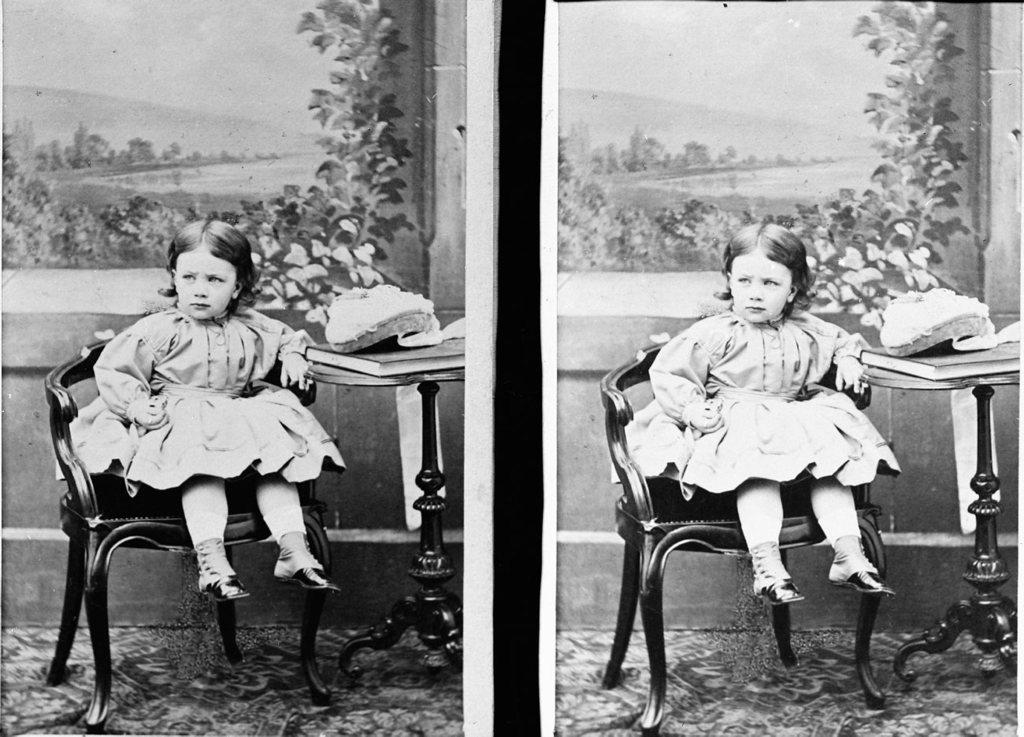What is the girl doing in the image? The girl is seated on a chair in the image. What object can be seen on a table in the image? There is a book on a table in the image. What type of pan is being used by the girl in the image? There is no pan present in the image; the girl is seated on a chair and there is a book on a table. 